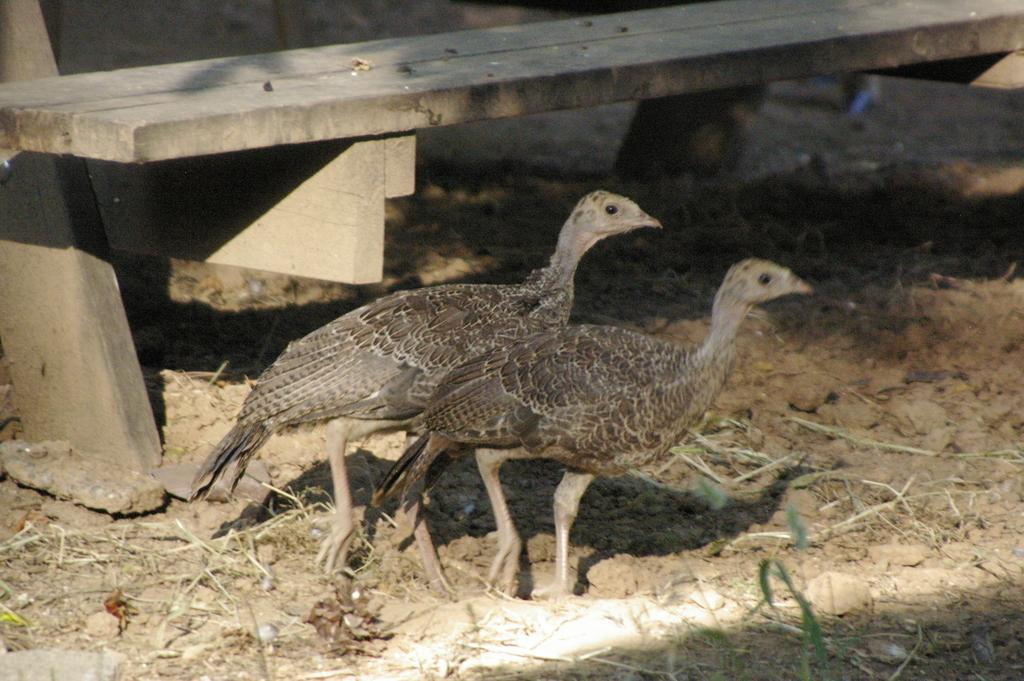What animals are in the center of the image? There are hens in the center of the image. What type of seating is visible in the background? There is a bench in the background of the image. What type of vegetation is visible at the bottom of the image? Grass is visible at the bottom of the image. What type of payment is being made by the hens in the image? There is no payment being made by the hens in the image; they are simply standing in the center of the image. 